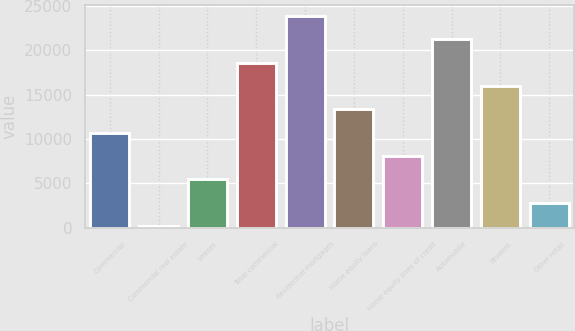Convert chart. <chart><loc_0><loc_0><loc_500><loc_500><bar_chart><fcel>Commercial<fcel>Commercial real estate<fcel>Leases<fcel>Total commercial<fcel>Residential mortgages<fcel>Home equity loans<fcel>Home equity lines of credit<fcel>Automobile<fcel>Student<fcel>Other retail<nl><fcel>10708.6<fcel>167<fcel>5437.8<fcel>18614.8<fcel>23885.6<fcel>13344<fcel>8073.2<fcel>21250.2<fcel>15979.4<fcel>2802.4<nl></chart> 